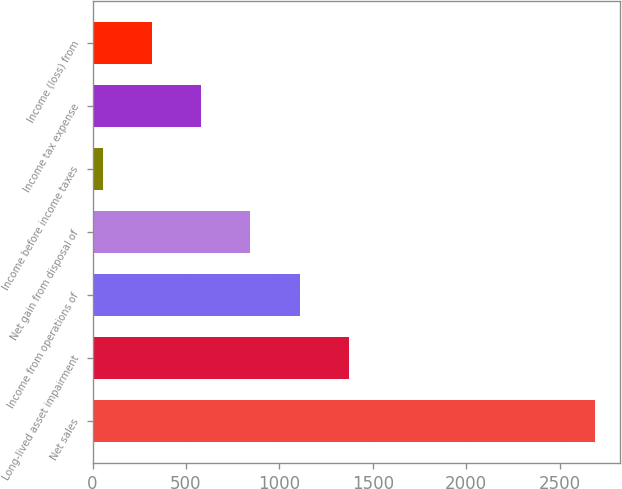<chart> <loc_0><loc_0><loc_500><loc_500><bar_chart><fcel>Net sales<fcel>Long-lived asset impairment<fcel>Income from operations of<fcel>Net gain from disposal of<fcel>Income before income taxes<fcel>Income tax expense<fcel>Income (loss) from<nl><fcel>2690<fcel>1372.15<fcel>1108.58<fcel>845.01<fcel>54.3<fcel>581.44<fcel>317.87<nl></chart> 